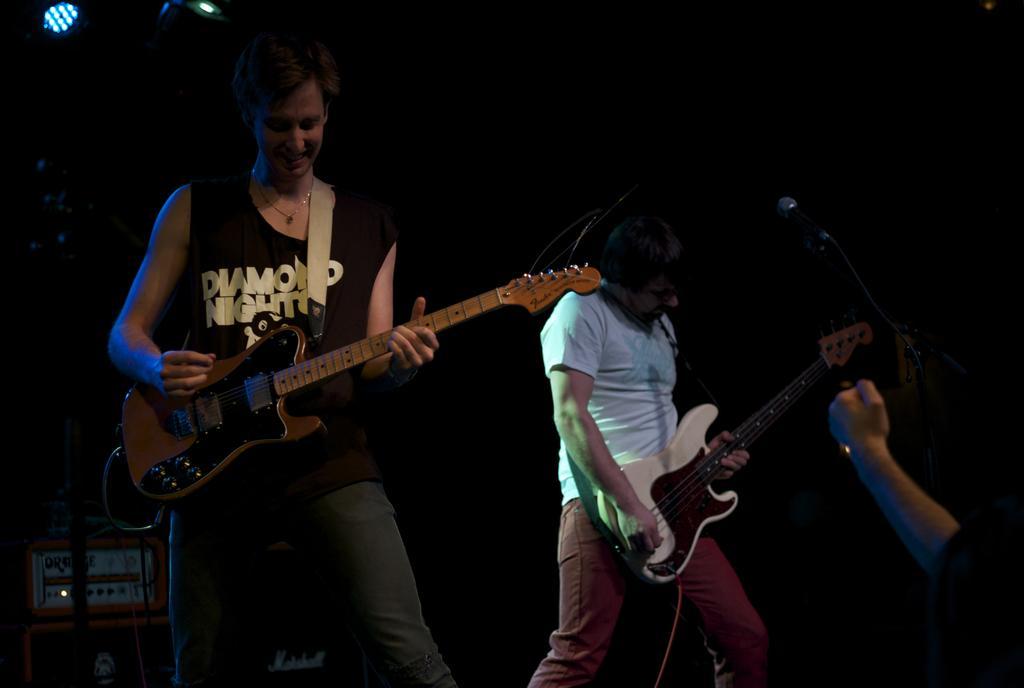Could you give a brief overview of what you see in this image? In this image there are 2 persons standing and playing a guitar. 